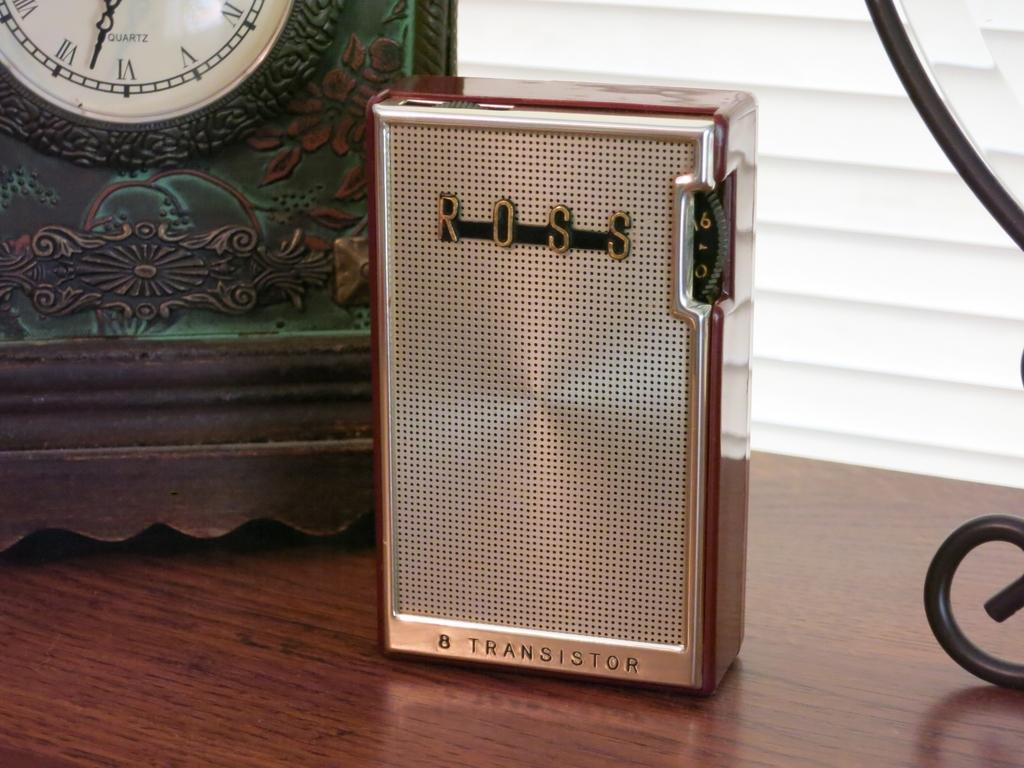<image>
Create a compact narrative representing the image presented. An old Ross transistor radio that is placed in front of a clock. 